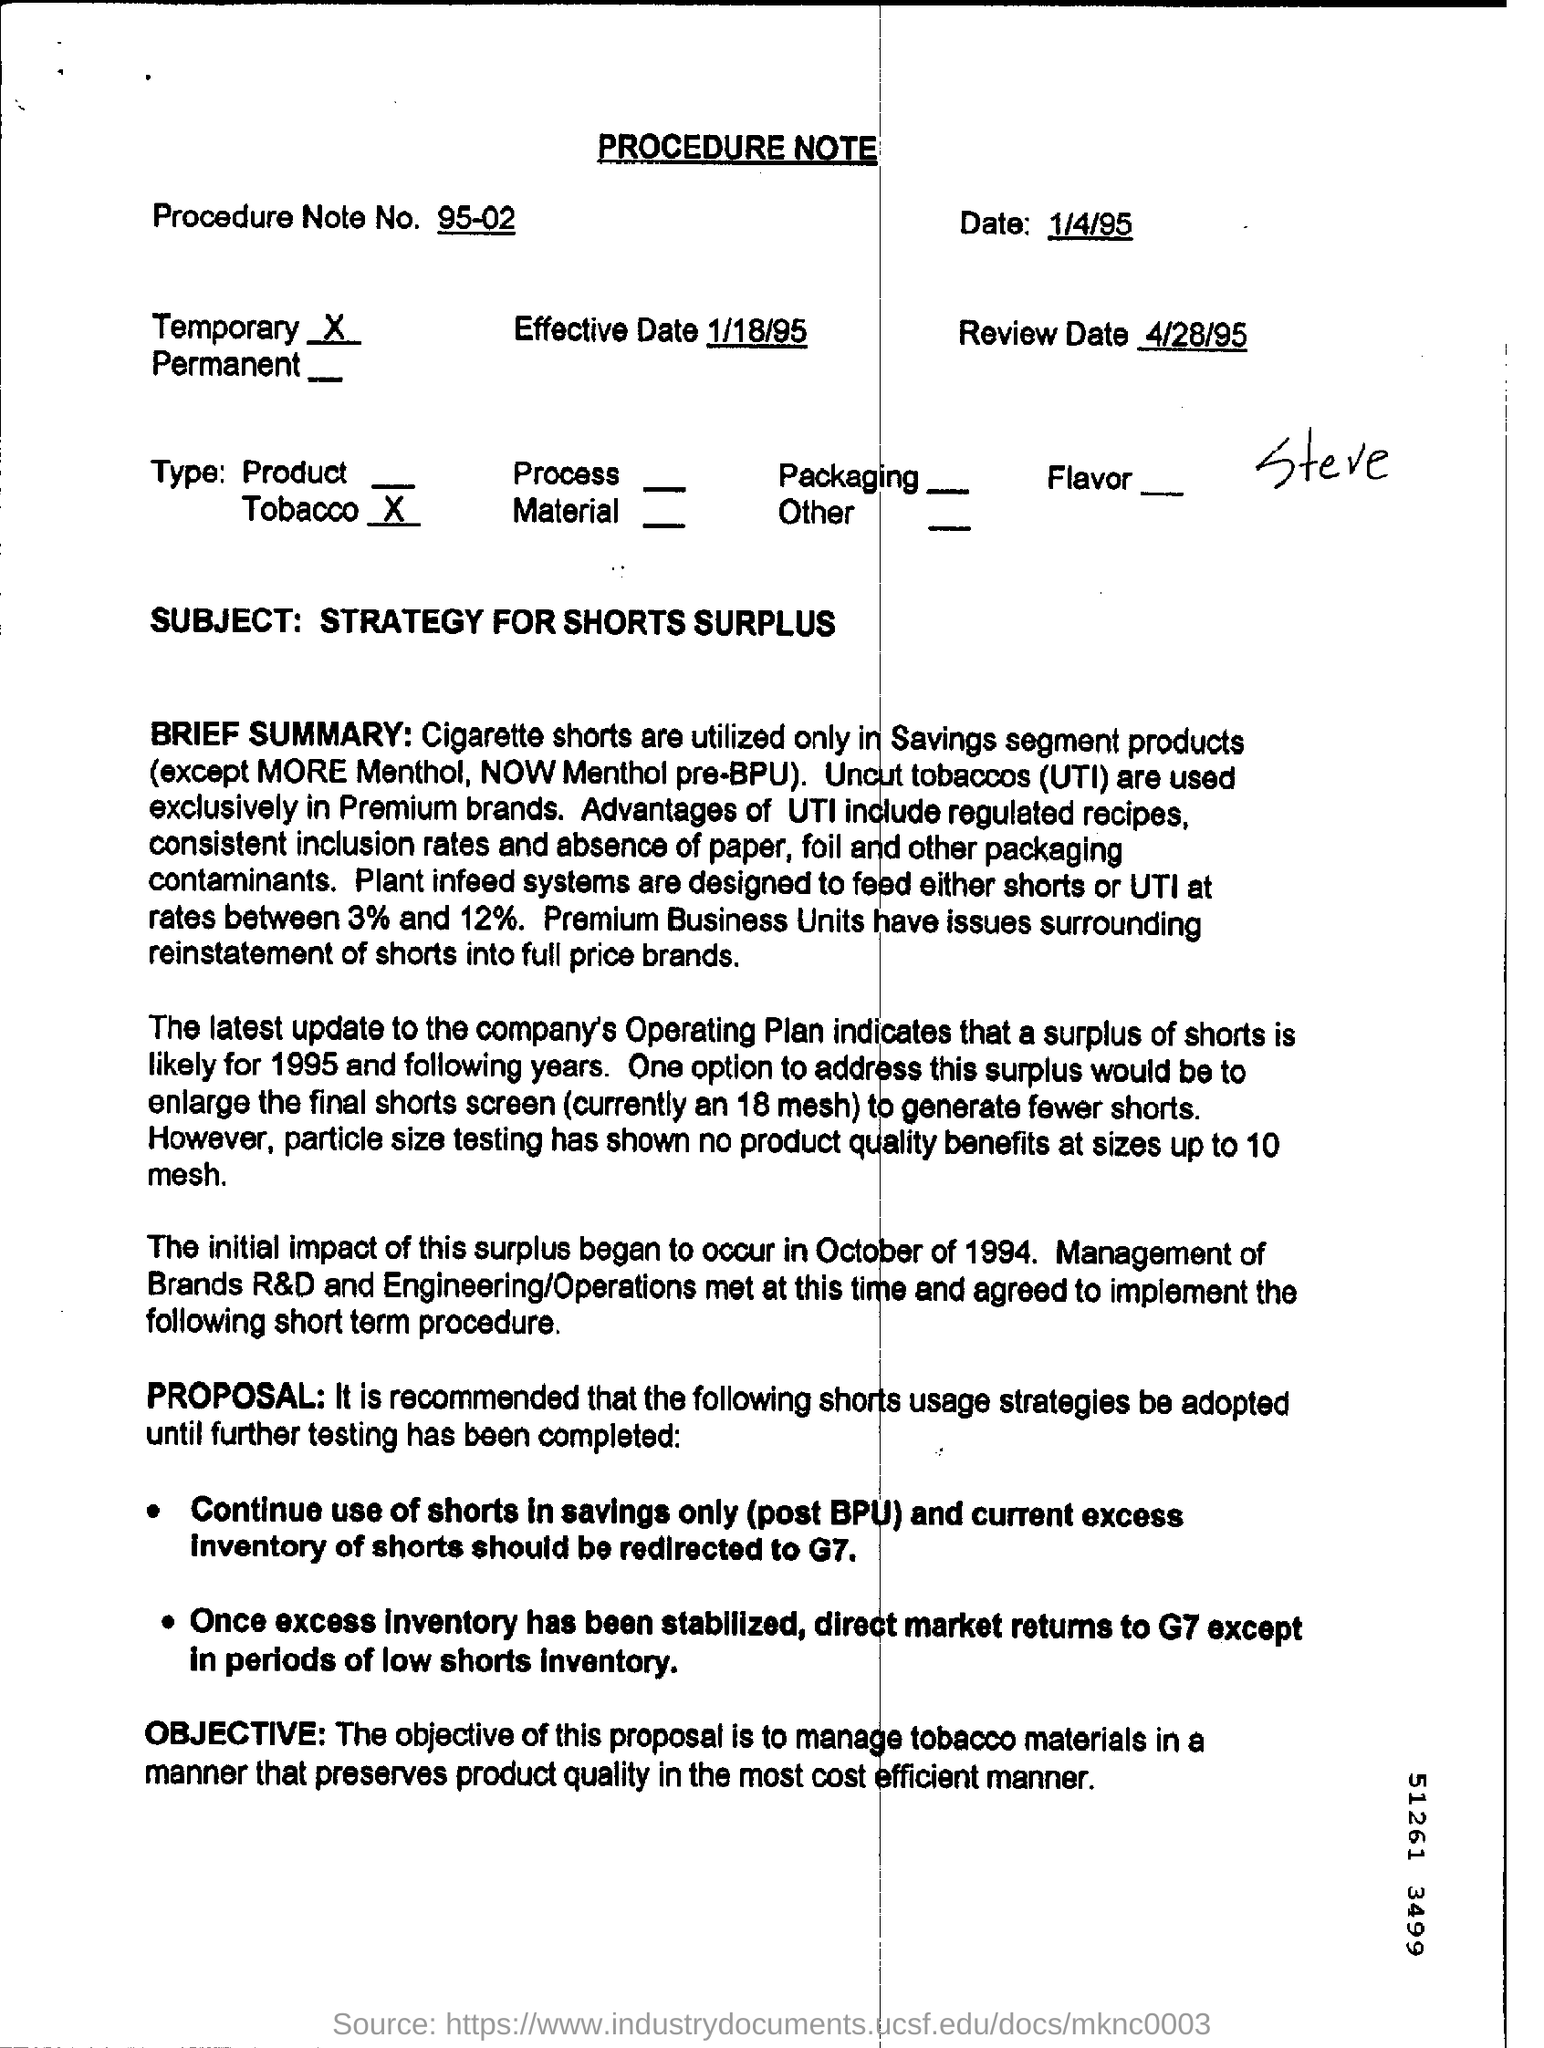Describe the subject matter of this document. The subject matter of this document is a strategy for managing a surplus of cigarette shorts within a tobacco company. It discusses the handling of the surplus and proposes certain strategies to manage the inventory efficiently. 